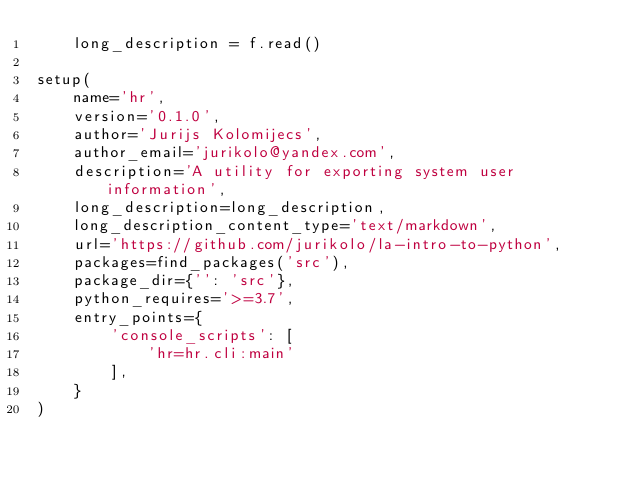<code> <loc_0><loc_0><loc_500><loc_500><_Python_>    long_description = f.read()

setup(
    name='hr',
    version='0.1.0',
    author='Jurijs Kolomijecs',
    author_email='jurikolo@yandex.com',
    description='A utility for exporting system user information',
    long_description=long_description,
    long_description_content_type='text/markdown',
    url='https://github.com/jurikolo/la-intro-to-python',
    packages=find_packages('src'),
    package_dir={'': 'src'},
    python_requires='>=3.7',
    entry_points={
        'console_scripts': [
            'hr=hr.cli:main'
        ],
    }
)</code> 